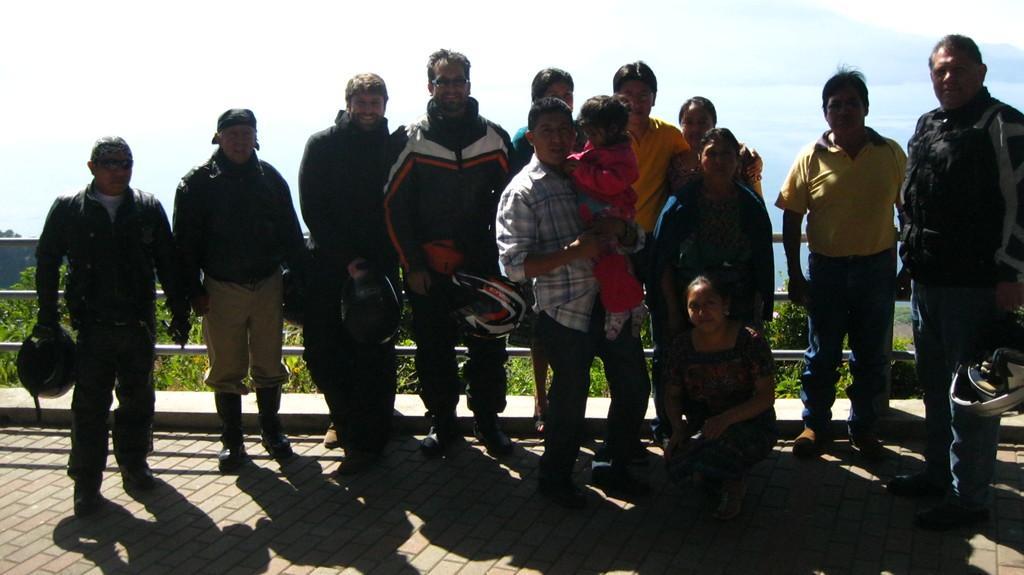Describe this image in one or two sentences. I n this image few persons are giving pose to a photograph, behind them there are iron roads ad trees, in the background there is cloudy sky. 